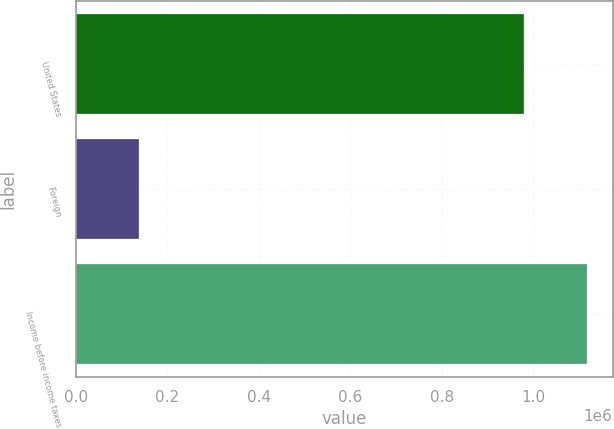Convert chart to OTSL. <chart><loc_0><loc_0><loc_500><loc_500><bar_chart><fcel>United States<fcel>Foreign<fcel>Income before income taxes<nl><fcel>978824<fcel>138915<fcel>1.11774e+06<nl></chart> 